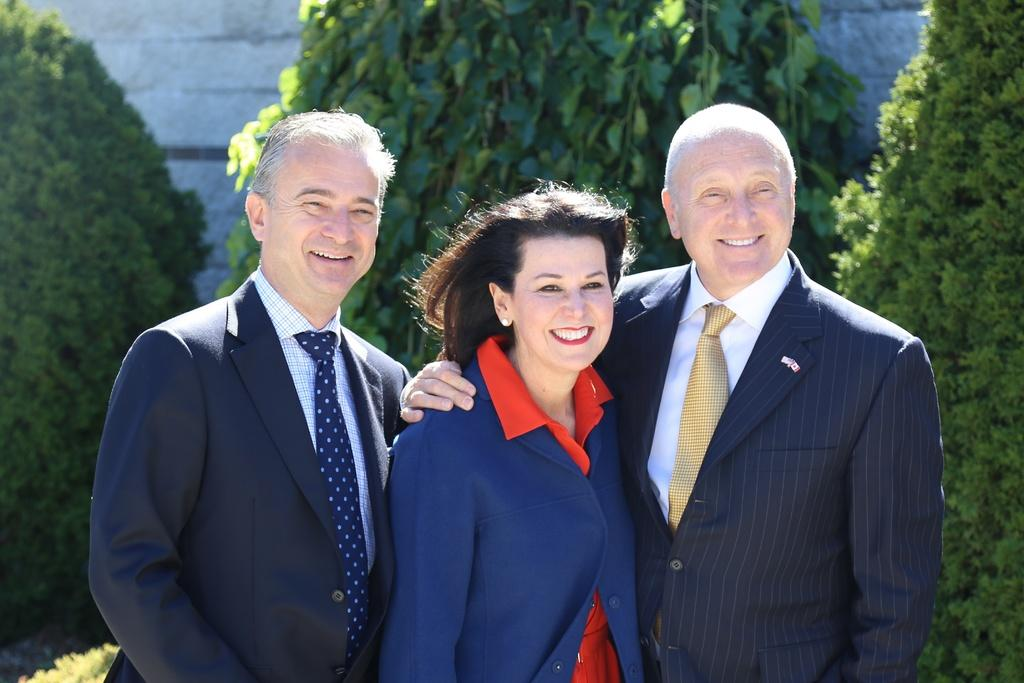What can be seen in the image? There are people standing in the image. What type of natural elements are present in the image? There are trees in the image. What man-made structure is visible in the image? There is a wall in the image. Where is the governor standing in the image? There is no governor present in the image. What type of kettle can be seen hanging from the trees in the image? There is no kettle present in the image, and no objects are hanging from the trees. 